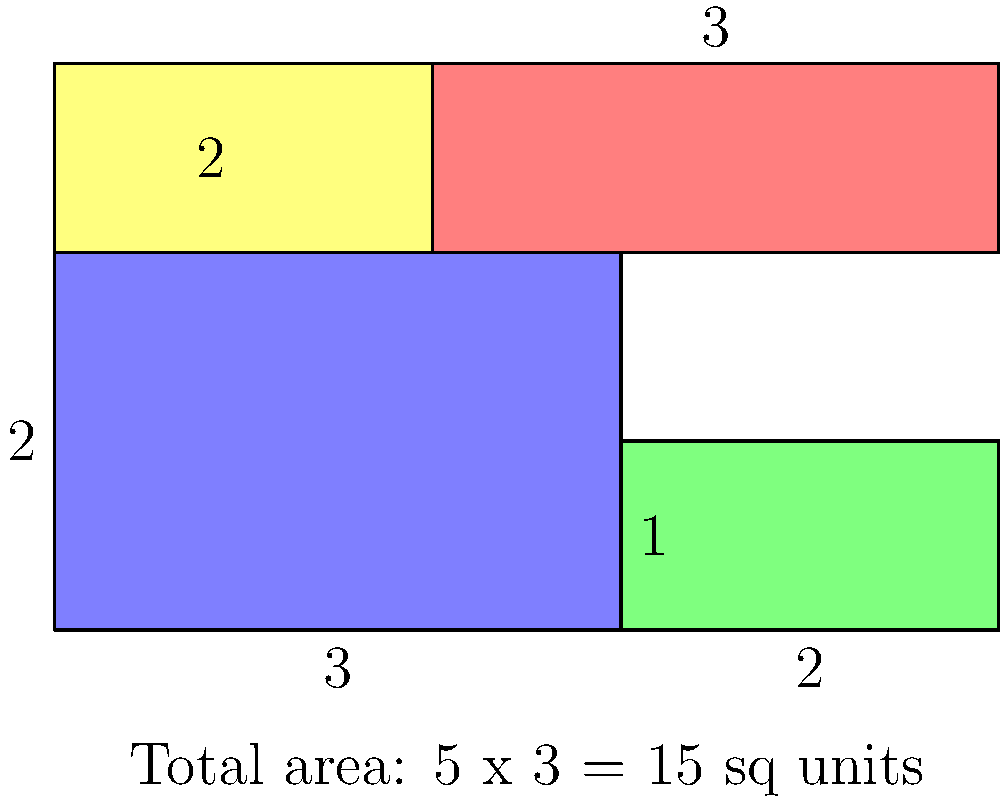As a startup developing lightweight materials for aircraft manufacturing, you need to optimize the packing of composite material sheets. Given the arrangement shown in the diagram, what is the minimum number of rectangular cuts needed to separate all four pieces, assuming cuts must be made along the entire length or width of the 5x3 unit area? To solve this problem, we need to analyze the arrangement and identify the minimum number of cuts that will separate all four pieces. Let's approach this step-by-step:

1. First, observe the arrangement:
   - The total area is 5 units wide and 3 units tall.
   - There are four rectangular pieces of different sizes.

2. Analyze the potential cuts:
   - Vertical cuts:
     a. A cut at x = 2 would separate the yellow piece from the red piece.
     b. A cut at x = 3 would separate the blue piece from the green piece.
   - Horizontal cuts:
     c. A cut at y = 1 would separate the green piece from the red piece.
     d. A cut at y = 2 would separate the blue piece from the yellow and red pieces.

3. Determine the minimum number of cuts:
   - We need at least one vertical cut and one horizontal cut to separate all pieces.
   - The cut at x = 3 (vertical) and y = 2 (horizontal) would be sufficient to separate all four pieces.

4. Verify the solution:
   - After making these two cuts, we would have:
     * The blue piece (bottom-left)
     * The green piece (bottom-right)
     * The yellow piece (top-left)
     * The red piece (top-right)

5. Conclusion:
   The minimum number of cuts needed is 2: one vertical cut and one horizontal cut.

This solution optimizes the cutting process, minimizing waste and time, which is crucial for efficient manufacturing in your lightweight materials startup.
Answer: 2 cuts 